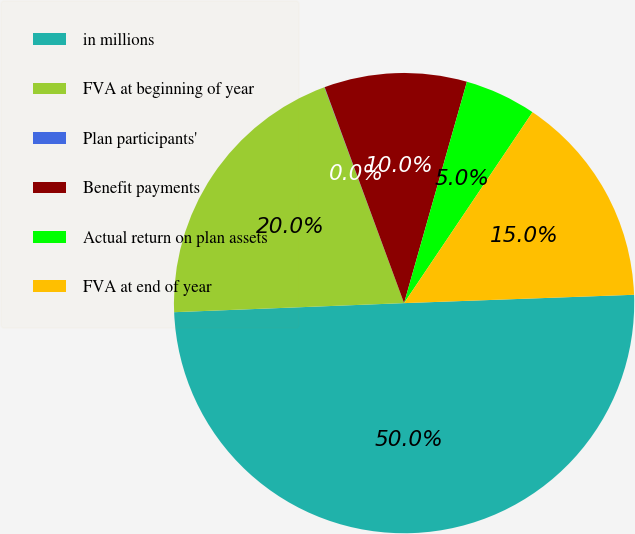<chart> <loc_0><loc_0><loc_500><loc_500><pie_chart><fcel>in millions<fcel>FVA at beginning of year<fcel>Plan participants'<fcel>Benefit payments<fcel>Actual return on plan assets<fcel>FVA at end of year<nl><fcel>49.95%<fcel>20.0%<fcel>0.02%<fcel>10.01%<fcel>5.02%<fcel>15.0%<nl></chart> 